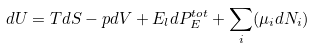<formula> <loc_0><loc_0><loc_500><loc_500>d U = T d S - p d V + E _ { l } d P ^ { t o t } _ { E } + \sum _ { i } ( { \mu _ { i } } d N _ { i } )</formula> 